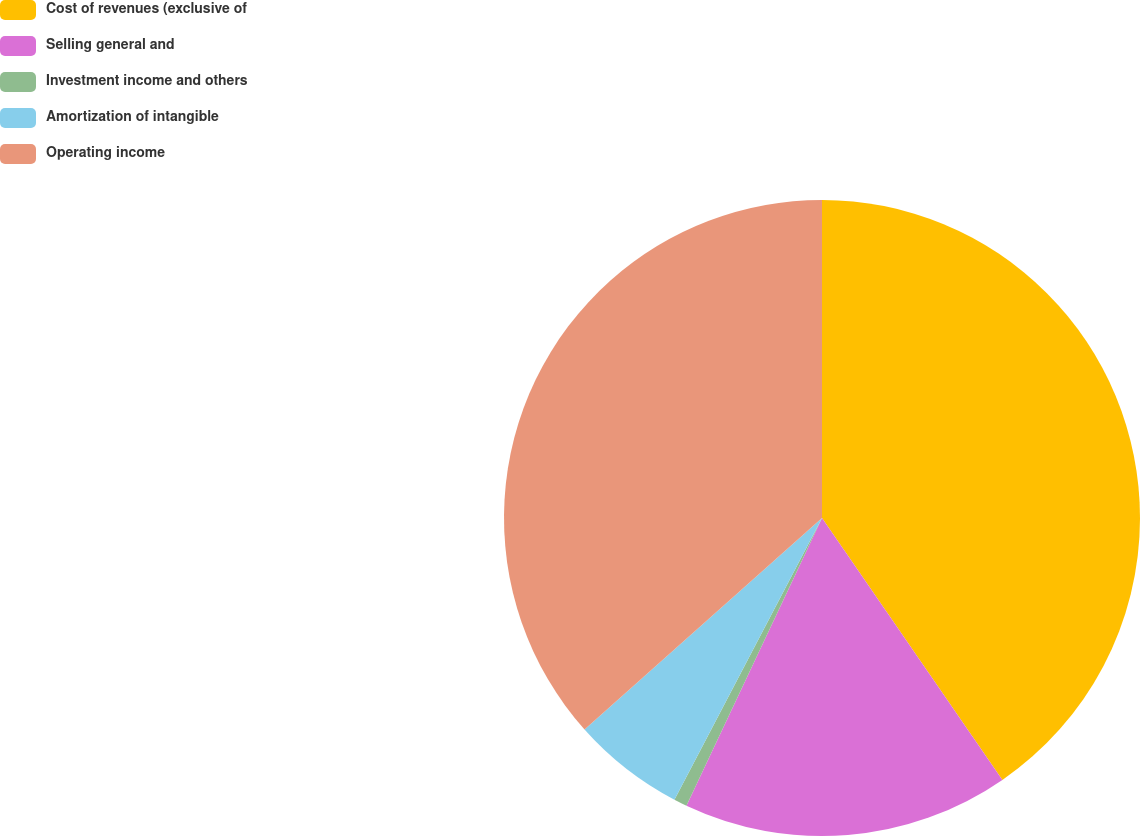Convert chart to OTSL. <chart><loc_0><loc_0><loc_500><loc_500><pie_chart><fcel>Cost of revenues (exclusive of<fcel>Selling general and<fcel>Investment income and others<fcel>Amortization of intangible<fcel>Operating income<nl><fcel>40.4%<fcel>16.61%<fcel>0.67%<fcel>5.74%<fcel>36.58%<nl></chart> 